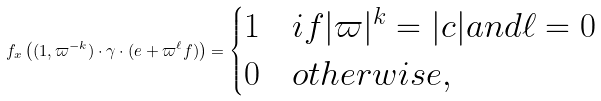<formula> <loc_0><loc_0><loc_500><loc_500>f _ { x } \left ( ( 1 , \varpi ^ { - k } ) \cdot \gamma \cdot ( e + \varpi ^ { \ell } f ) \right ) = \begin{cases} 1 & i f | \varpi | ^ { k } = | c | a n d \ell = 0 \\ 0 & o t h e r w i s e , \end{cases}</formula> 